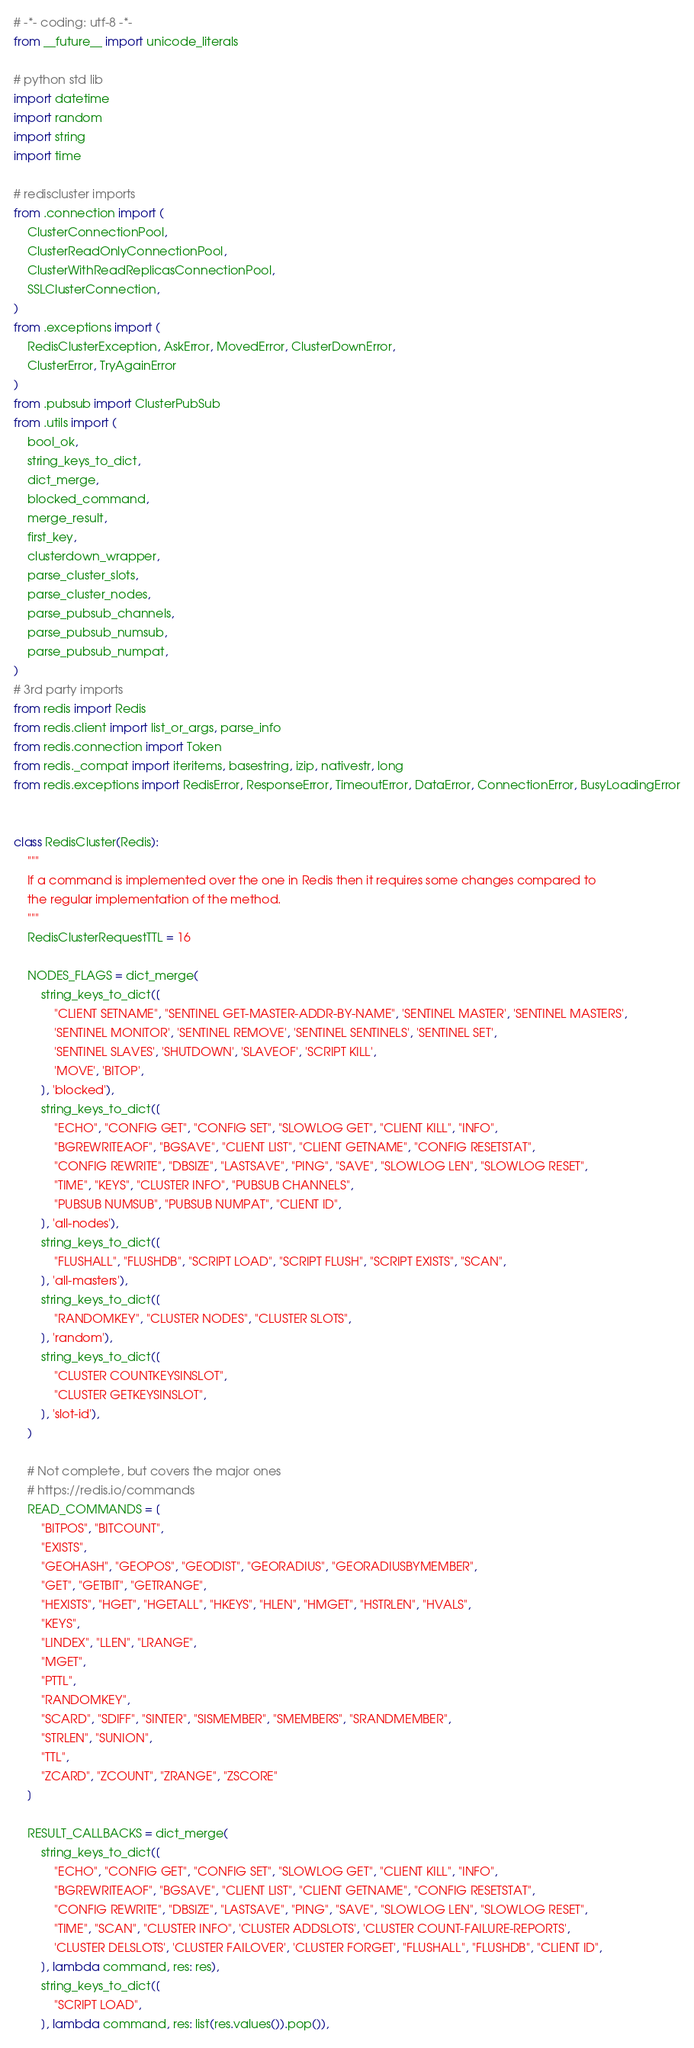Convert code to text. <code><loc_0><loc_0><loc_500><loc_500><_Python_># -*- coding: utf-8 -*-
from __future__ import unicode_literals

# python std lib
import datetime
import random
import string
import time

# rediscluster imports
from .connection import (
    ClusterConnectionPool,
    ClusterReadOnlyConnectionPool,
    ClusterWithReadReplicasConnectionPool,
    SSLClusterConnection,
)
from .exceptions import (
    RedisClusterException, AskError, MovedError, ClusterDownError,
    ClusterError, TryAgainError
)
from .pubsub import ClusterPubSub
from .utils import (
    bool_ok,
    string_keys_to_dict,
    dict_merge,
    blocked_command,
    merge_result,
    first_key,
    clusterdown_wrapper,
    parse_cluster_slots,
    parse_cluster_nodes,
    parse_pubsub_channels,
    parse_pubsub_numsub,
    parse_pubsub_numpat,
)
# 3rd party imports
from redis import Redis
from redis.client import list_or_args, parse_info
from redis.connection import Token
from redis._compat import iteritems, basestring, izip, nativestr, long
from redis.exceptions import RedisError, ResponseError, TimeoutError, DataError, ConnectionError, BusyLoadingError


class RedisCluster(Redis):
    """
    If a command is implemented over the one in Redis then it requires some changes compared to
    the regular implementation of the method.
    """
    RedisClusterRequestTTL = 16

    NODES_FLAGS = dict_merge(
        string_keys_to_dict([
            "CLIENT SETNAME", "SENTINEL GET-MASTER-ADDR-BY-NAME", 'SENTINEL MASTER', 'SENTINEL MASTERS',
            'SENTINEL MONITOR', 'SENTINEL REMOVE', 'SENTINEL SENTINELS', 'SENTINEL SET',
            'SENTINEL SLAVES', 'SHUTDOWN', 'SLAVEOF', 'SCRIPT KILL',
            'MOVE', 'BITOP',
        ], 'blocked'),
        string_keys_to_dict([
            "ECHO", "CONFIG GET", "CONFIG SET", "SLOWLOG GET", "CLIENT KILL", "INFO",
            "BGREWRITEAOF", "BGSAVE", "CLIENT LIST", "CLIENT GETNAME", "CONFIG RESETSTAT",
            "CONFIG REWRITE", "DBSIZE", "LASTSAVE", "PING", "SAVE", "SLOWLOG LEN", "SLOWLOG RESET",
            "TIME", "KEYS", "CLUSTER INFO", "PUBSUB CHANNELS",
            "PUBSUB NUMSUB", "PUBSUB NUMPAT", "CLIENT ID",
        ], 'all-nodes'),
        string_keys_to_dict([
            "FLUSHALL", "FLUSHDB", "SCRIPT LOAD", "SCRIPT FLUSH", "SCRIPT EXISTS", "SCAN",
        ], 'all-masters'),
        string_keys_to_dict([
            "RANDOMKEY", "CLUSTER NODES", "CLUSTER SLOTS",
        ], 'random'),
        string_keys_to_dict([
            "CLUSTER COUNTKEYSINSLOT",
            "CLUSTER GETKEYSINSLOT",
        ], 'slot-id'),
    )

    # Not complete, but covers the major ones
    # https://redis.io/commands
    READ_COMMANDS = [
        "BITPOS", "BITCOUNT",
        "EXISTS",
        "GEOHASH", "GEOPOS", "GEODIST", "GEORADIUS", "GEORADIUSBYMEMBER",
        "GET", "GETBIT", "GETRANGE",
        "HEXISTS", "HGET", "HGETALL", "HKEYS", "HLEN", "HMGET", "HSTRLEN", "HVALS",
        "KEYS",
        "LINDEX", "LLEN", "LRANGE",
        "MGET",
        "PTTL",
        "RANDOMKEY",
        "SCARD", "SDIFF", "SINTER", "SISMEMBER", "SMEMBERS", "SRANDMEMBER",
        "STRLEN", "SUNION",
        "TTL",
        "ZCARD", "ZCOUNT", "ZRANGE", "ZSCORE"
    ]

    RESULT_CALLBACKS = dict_merge(
        string_keys_to_dict([
            "ECHO", "CONFIG GET", "CONFIG SET", "SLOWLOG GET", "CLIENT KILL", "INFO",
            "BGREWRITEAOF", "BGSAVE", "CLIENT LIST", "CLIENT GETNAME", "CONFIG RESETSTAT",
            "CONFIG REWRITE", "DBSIZE", "LASTSAVE", "PING", "SAVE", "SLOWLOG LEN", "SLOWLOG RESET",
            "TIME", "SCAN", "CLUSTER INFO", 'CLUSTER ADDSLOTS', 'CLUSTER COUNT-FAILURE-REPORTS',
            'CLUSTER DELSLOTS', 'CLUSTER FAILOVER', 'CLUSTER FORGET', "FLUSHALL", "FLUSHDB", "CLIENT ID",
        ], lambda command, res: res),
        string_keys_to_dict([
            "SCRIPT LOAD",
        ], lambda command, res: list(res.values()).pop()),</code> 